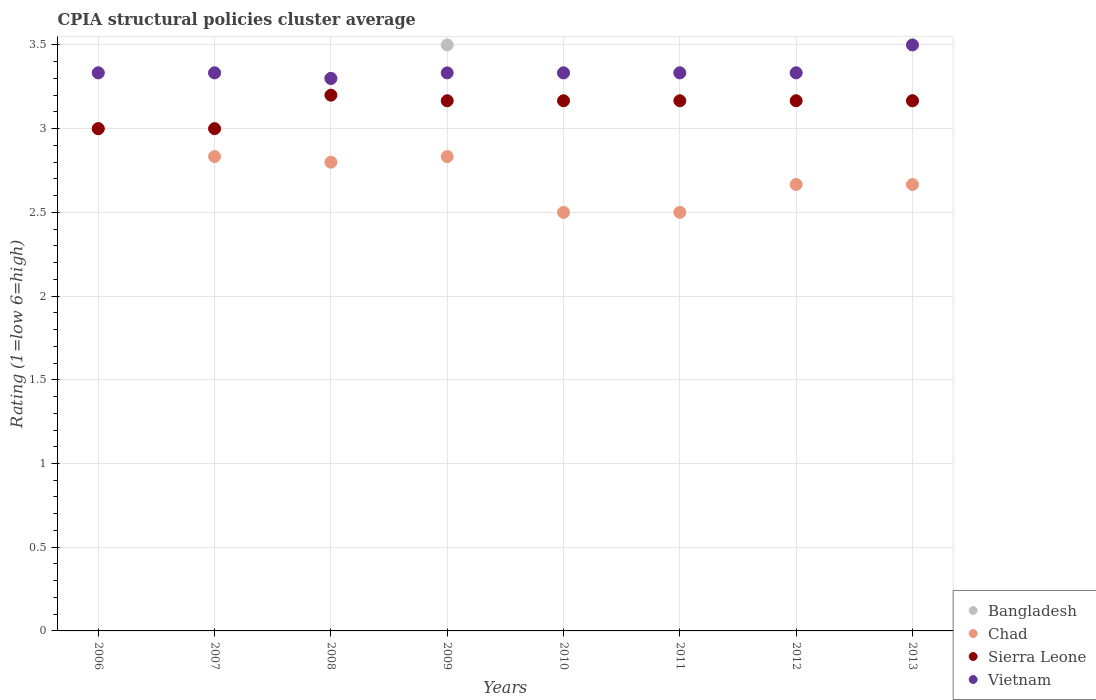How many different coloured dotlines are there?
Your answer should be very brief. 4. Is the number of dotlines equal to the number of legend labels?
Provide a short and direct response. Yes. What is the CPIA rating in Bangladesh in 2012?
Your response must be concise. 3.33. Across all years, what is the maximum CPIA rating in Bangladesh?
Keep it short and to the point. 3.5. What is the total CPIA rating in Bangladesh in the graph?
Provide a succinct answer. 26.63. What is the difference between the CPIA rating in Chad in 2006 and the CPIA rating in Vietnam in 2010?
Your response must be concise. -0.33. What is the average CPIA rating in Chad per year?
Your response must be concise. 2.72. In the year 2007, what is the difference between the CPIA rating in Chad and CPIA rating in Vietnam?
Your response must be concise. -0.5. Is the CPIA rating in Vietnam in 2008 less than that in 2010?
Your response must be concise. Yes. What is the difference between the highest and the second highest CPIA rating in Bangladesh?
Provide a succinct answer. 0.17. What is the difference between the highest and the lowest CPIA rating in Bangladesh?
Your answer should be very brief. 0.33. Is the sum of the CPIA rating in Vietnam in 2007 and 2010 greater than the maximum CPIA rating in Bangladesh across all years?
Give a very brief answer. Yes. Is it the case that in every year, the sum of the CPIA rating in Sierra Leone and CPIA rating in Chad  is greater than the sum of CPIA rating in Bangladesh and CPIA rating in Vietnam?
Ensure brevity in your answer.  No. Does the CPIA rating in Bangladesh monotonically increase over the years?
Offer a terse response. No. Is the CPIA rating in Bangladesh strictly less than the CPIA rating in Sierra Leone over the years?
Your answer should be compact. No. How many years are there in the graph?
Keep it short and to the point. 8. Does the graph contain any zero values?
Ensure brevity in your answer.  No. Where does the legend appear in the graph?
Offer a terse response. Bottom right. How are the legend labels stacked?
Give a very brief answer. Vertical. What is the title of the graph?
Provide a short and direct response. CPIA structural policies cluster average. What is the Rating (1=low 6=high) in Bangladesh in 2006?
Your answer should be very brief. 3.33. What is the Rating (1=low 6=high) in Sierra Leone in 2006?
Give a very brief answer. 3. What is the Rating (1=low 6=high) in Vietnam in 2006?
Your answer should be very brief. 3.33. What is the Rating (1=low 6=high) of Bangladesh in 2007?
Keep it short and to the point. 3.33. What is the Rating (1=low 6=high) of Chad in 2007?
Your answer should be very brief. 2.83. What is the Rating (1=low 6=high) of Vietnam in 2007?
Offer a very short reply. 3.33. What is the Rating (1=low 6=high) in Bangladesh in 2008?
Your response must be concise. 3.3. What is the Rating (1=low 6=high) of Chad in 2008?
Keep it short and to the point. 2.8. What is the Rating (1=low 6=high) in Sierra Leone in 2008?
Provide a succinct answer. 3.2. What is the Rating (1=low 6=high) of Vietnam in 2008?
Your response must be concise. 3.3. What is the Rating (1=low 6=high) in Bangladesh in 2009?
Ensure brevity in your answer.  3.5. What is the Rating (1=low 6=high) in Chad in 2009?
Make the answer very short. 2.83. What is the Rating (1=low 6=high) of Sierra Leone in 2009?
Your response must be concise. 3.17. What is the Rating (1=low 6=high) of Vietnam in 2009?
Make the answer very short. 3.33. What is the Rating (1=low 6=high) in Bangladesh in 2010?
Offer a very short reply. 3.33. What is the Rating (1=low 6=high) in Sierra Leone in 2010?
Your answer should be very brief. 3.17. What is the Rating (1=low 6=high) in Vietnam in 2010?
Make the answer very short. 3.33. What is the Rating (1=low 6=high) of Bangladesh in 2011?
Provide a succinct answer. 3.33. What is the Rating (1=low 6=high) in Sierra Leone in 2011?
Your answer should be compact. 3.17. What is the Rating (1=low 6=high) of Vietnam in 2011?
Keep it short and to the point. 3.33. What is the Rating (1=low 6=high) in Bangladesh in 2012?
Make the answer very short. 3.33. What is the Rating (1=low 6=high) in Chad in 2012?
Offer a terse response. 2.67. What is the Rating (1=low 6=high) in Sierra Leone in 2012?
Ensure brevity in your answer.  3.17. What is the Rating (1=low 6=high) in Vietnam in 2012?
Your answer should be compact. 3.33. What is the Rating (1=low 6=high) in Bangladesh in 2013?
Your response must be concise. 3.17. What is the Rating (1=low 6=high) of Chad in 2013?
Make the answer very short. 2.67. What is the Rating (1=low 6=high) of Sierra Leone in 2013?
Your response must be concise. 3.17. What is the Rating (1=low 6=high) in Vietnam in 2013?
Offer a terse response. 3.5. Across all years, what is the maximum Rating (1=low 6=high) in Chad?
Keep it short and to the point. 3. Across all years, what is the maximum Rating (1=low 6=high) in Vietnam?
Your answer should be compact. 3.5. Across all years, what is the minimum Rating (1=low 6=high) in Bangladesh?
Your answer should be compact. 3.17. What is the total Rating (1=low 6=high) in Bangladesh in the graph?
Offer a terse response. 26.63. What is the total Rating (1=low 6=high) of Chad in the graph?
Provide a short and direct response. 21.8. What is the total Rating (1=low 6=high) in Sierra Leone in the graph?
Ensure brevity in your answer.  25.03. What is the total Rating (1=low 6=high) of Vietnam in the graph?
Offer a terse response. 26.8. What is the difference between the Rating (1=low 6=high) of Bangladesh in 2006 and that in 2007?
Give a very brief answer. 0. What is the difference between the Rating (1=low 6=high) in Chad in 2006 and that in 2007?
Provide a short and direct response. 0.17. What is the difference between the Rating (1=low 6=high) of Sierra Leone in 2006 and that in 2007?
Ensure brevity in your answer.  0. What is the difference between the Rating (1=low 6=high) in Vietnam in 2006 and that in 2007?
Your answer should be compact. 0. What is the difference between the Rating (1=low 6=high) in Chad in 2006 and that in 2008?
Provide a succinct answer. 0.2. What is the difference between the Rating (1=low 6=high) of Vietnam in 2006 and that in 2008?
Your answer should be very brief. 0.03. What is the difference between the Rating (1=low 6=high) of Chad in 2006 and that in 2009?
Your answer should be compact. 0.17. What is the difference between the Rating (1=low 6=high) in Sierra Leone in 2006 and that in 2009?
Ensure brevity in your answer.  -0.17. What is the difference between the Rating (1=low 6=high) in Bangladesh in 2006 and that in 2010?
Ensure brevity in your answer.  0. What is the difference between the Rating (1=low 6=high) of Sierra Leone in 2006 and that in 2010?
Keep it short and to the point. -0.17. What is the difference between the Rating (1=low 6=high) in Vietnam in 2006 and that in 2010?
Offer a very short reply. 0. What is the difference between the Rating (1=low 6=high) in Vietnam in 2006 and that in 2011?
Provide a succinct answer. 0. What is the difference between the Rating (1=low 6=high) of Bangladesh in 2006 and that in 2013?
Your answer should be compact. 0.17. What is the difference between the Rating (1=low 6=high) in Chad in 2006 and that in 2013?
Make the answer very short. 0.33. What is the difference between the Rating (1=low 6=high) of Sierra Leone in 2006 and that in 2013?
Give a very brief answer. -0.17. What is the difference between the Rating (1=low 6=high) in Bangladesh in 2007 and that in 2008?
Provide a succinct answer. 0.03. What is the difference between the Rating (1=low 6=high) in Chad in 2007 and that in 2008?
Your answer should be very brief. 0.03. What is the difference between the Rating (1=low 6=high) in Sierra Leone in 2007 and that in 2008?
Offer a very short reply. -0.2. What is the difference between the Rating (1=low 6=high) of Vietnam in 2007 and that in 2008?
Your response must be concise. 0.03. What is the difference between the Rating (1=low 6=high) of Chad in 2007 and that in 2009?
Ensure brevity in your answer.  0. What is the difference between the Rating (1=low 6=high) in Sierra Leone in 2007 and that in 2009?
Offer a very short reply. -0.17. What is the difference between the Rating (1=low 6=high) in Vietnam in 2007 and that in 2009?
Keep it short and to the point. 0. What is the difference between the Rating (1=low 6=high) of Sierra Leone in 2007 and that in 2010?
Your response must be concise. -0.17. What is the difference between the Rating (1=low 6=high) of Vietnam in 2007 and that in 2010?
Your answer should be very brief. 0. What is the difference between the Rating (1=low 6=high) in Sierra Leone in 2007 and that in 2012?
Keep it short and to the point. -0.17. What is the difference between the Rating (1=low 6=high) of Bangladesh in 2007 and that in 2013?
Your response must be concise. 0.17. What is the difference between the Rating (1=low 6=high) of Chad in 2007 and that in 2013?
Keep it short and to the point. 0.17. What is the difference between the Rating (1=low 6=high) of Vietnam in 2007 and that in 2013?
Offer a terse response. -0.17. What is the difference between the Rating (1=low 6=high) of Chad in 2008 and that in 2009?
Your response must be concise. -0.03. What is the difference between the Rating (1=low 6=high) of Vietnam in 2008 and that in 2009?
Keep it short and to the point. -0.03. What is the difference between the Rating (1=low 6=high) in Bangladesh in 2008 and that in 2010?
Provide a short and direct response. -0.03. What is the difference between the Rating (1=low 6=high) of Vietnam in 2008 and that in 2010?
Keep it short and to the point. -0.03. What is the difference between the Rating (1=low 6=high) in Bangladesh in 2008 and that in 2011?
Provide a short and direct response. -0.03. What is the difference between the Rating (1=low 6=high) of Chad in 2008 and that in 2011?
Offer a very short reply. 0.3. What is the difference between the Rating (1=low 6=high) in Vietnam in 2008 and that in 2011?
Your answer should be very brief. -0.03. What is the difference between the Rating (1=low 6=high) in Bangladesh in 2008 and that in 2012?
Your answer should be very brief. -0.03. What is the difference between the Rating (1=low 6=high) of Chad in 2008 and that in 2012?
Keep it short and to the point. 0.13. What is the difference between the Rating (1=low 6=high) of Vietnam in 2008 and that in 2012?
Give a very brief answer. -0.03. What is the difference between the Rating (1=low 6=high) in Bangladesh in 2008 and that in 2013?
Make the answer very short. 0.13. What is the difference between the Rating (1=low 6=high) of Chad in 2008 and that in 2013?
Your response must be concise. 0.13. What is the difference between the Rating (1=low 6=high) of Sierra Leone in 2008 and that in 2013?
Offer a very short reply. 0.03. What is the difference between the Rating (1=low 6=high) in Chad in 2009 and that in 2010?
Give a very brief answer. 0.33. What is the difference between the Rating (1=low 6=high) of Bangladesh in 2009 and that in 2011?
Keep it short and to the point. 0.17. What is the difference between the Rating (1=low 6=high) of Chad in 2009 and that in 2011?
Offer a terse response. 0.33. What is the difference between the Rating (1=low 6=high) in Bangladesh in 2009 and that in 2012?
Your response must be concise. 0.17. What is the difference between the Rating (1=low 6=high) in Chad in 2009 and that in 2012?
Your answer should be compact. 0.17. What is the difference between the Rating (1=low 6=high) of Chad in 2010 and that in 2011?
Provide a short and direct response. 0. What is the difference between the Rating (1=low 6=high) in Sierra Leone in 2010 and that in 2011?
Give a very brief answer. 0. What is the difference between the Rating (1=low 6=high) of Chad in 2010 and that in 2012?
Give a very brief answer. -0.17. What is the difference between the Rating (1=low 6=high) of Bangladesh in 2010 and that in 2013?
Your response must be concise. 0.17. What is the difference between the Rating (1=low 6=high) in Chad in 2010 and that in 2013?
Your answer should be very brief. -0.17. What is the difference between the Rating (1=low 6=high) in Sierra Leone in 2010 and that in 2013?
Ensure brevity in your answer.  0. What is the difference between the Rating (1=low 6=high) in Vietnam in 2010 and that in 2013?
Ensure brevity in your answer.  -0.17. What is the difference between the Rating (1=low 6=high) in Bangladesh in 2011 and that in 2012?
Your answer should be compact. 0. What is the difference between the Rating (1=low 6=high) in Sierra Leone in 2011 and that in 2012?
Your answer should be very brief. 0. What is the difference between the Rating (1=low 6=high) in Bangladesh in 2011 and that in 2013?
Provide a short and direct response. 0.17. What is the difference between the Rating (1=low 6=high) of Sierra Leone in 2011 and that in 2013?
Your answer should be compact. 0. What is the difference between the Rating (1=low 6=high) in Vietnam in 2011 and that in 2013?
Give a very brief answer. -0.17. What is the difference between the Rating (1=low 6=high) of Bangladesh in 2012 and that in 2013?
Provide a short and direct response. 0.17. What is the difference between the Rating (1=low 6=high) of Chad in 2012 and that in 2013?
Provide a short and direct response. 0. What is the difference between the Rating (1=low 6=high) in Sierra Leone in 2012 and that in 2013?
Offer a terse response. 0. What is the difference between the Rating (1=low 6=high) in Vietnam in 2012 and that in 2013?
Your response must be concise. -0.17. What is the difference between the Rating (1=low 6=high) of Bangladesh in 2006 and the Rating (1=low 6=high) of Vietnam in 2007?
Your answer should be very brief. 0. What is the difference between the Rating (1=low 6=high) of Chad in 2006 and the Rating (1=low 6=high) of Vietnam in 2007?
Your answer should be compact. -0.33. What is the difference between the Rating (1=low 6=high) of Bangladesh in 2006 and the Rating (1=low 6=high) of Chad in 2008?
Keep it short and to the point. 0.53. What is the difference between the Rating (1=low 6=high) in Bangladesh in 2006 and the Rating (1=low 6=high) in Sierra Leone in 2008?
Your response must be concise. 0.13. What is the difference between the Rating (1=low 6=high) of Bangladesh in 2006 and the Rating (1=low 6=high) of Vietnam in 2008?
Give a very brief answer. 0.03. What is the difference between the Rating (1=low 6=high) in Chad in 2006 and the Rating (1=low 6=high) in Sierra Leone in 2008?
Offer a very short reply. -0.2. What is the difference between the Rating (1=low 6=high) of Sierra Leone in 2006 and the Rating (1=low 6=high) of Vietnam in 2008?
Offer a very short reply. -0.3. What is the difference between the Rating (1=low 6=high) of Bangladesh in 2006 and the Rating (1=low 6=high) of Vietnam in 2009?
Ensure brevity in your answer.  0. What is the difference between the Rating (1=low 6=high) of Chad in 2006 and the Rating (1=low 6=high) of Sierra Leone in 2009?
Provide a succinct answer. -0.17. What is the difference between the Rating (1=low 6=high) in Chad in 2006 and the Rating (1=low 6=high) in Vietnam in 2009?
Your answer should be compact. -0.33. What is the difference between the Rating (1=low 6=high) in Sierra Leone in 2006 and the Rating (1=low 6=high) in Vietnam in 2009?
Your response must be concise. -0.33. What is the difference between the Rating (1=low 6=high) of Bangladesh in 2006 and the Rating (1=low 6=high) of Chad in 2010?
Give a very brief answer. 0.83. What is the difference between the Rating (1=low 6=high) in Bangladesh in 2006 and the Rating (1=low 6=high) in Sierra Leone in 2010?
Your answer should be compact. 0.17. What is the difference between the Rating (1=low 6=high) of Bangladesh in 2006 and the Rating (1=low 6=high) of Vietnam in 2010?
Make the answer very short. 0. What is the difference between the Rating (1=low 6=high) of Sierra Leone in 2006 and the Rating (1=low 6=high) of Vietnam in 2010?
Your answer should be very brief. -0.33. What is the difference between the Rating (1=low 6=high) in Chad in 2006 and the Rating (1=low 6=high) in Sierra Leone in 2011?
Ensure brevity in your answer.  -0.17. What is the difference between the Rating (1=low 6=high) of Bangladesh in 2006 and the Rating (1=low 6=high) of Chad in 2012?
Give a very brief answer. 0.67. What is the difference between the Rating (1=low 6=high) in Bangladesh in 2006 and the Rating (1=low 6=high) in Vietnam in 2012?
Ensure brevity in your answer.  0. What is the difference between the Rating (1=low 6=high) in Chad in 2006 and the Rating (1=low 6=high) in Sierra Leone in 2012?
Your response must be concise. -0.17. What is the difference between the Rating (1=low 6=high) of Chad in 2006 and the Rating (1=low 6=high) of Vietnam in 2012?
Provide a short and direct response. -0.33. What is the difference between the Rating (1=low 6=high) in Sierra Leone in 2006 and the Rating (1=low 6=high) in Vietnam in 2012?
Keep it short and to the point. -0.33. What is the difference between the Rating (1=low 6=high) in Bangladesh in 2006 and the Rating (1=low 6=high) in Chad in 2013?
Offer a terse response. 0.67. What is the difference between the Rating (1=low 6=high) in Bangladesh in 2006 and the Rating (1=low 6=high) in Sierra Leone in 2013?
Provide a short and direct response. 0.17. What is the difference between the Rating (1=low 6=high) in Bangladesh in 2006 and the Rating (1=low 6=high) in Vietnam in 2013?
Your answer should be very brief. -0.17. What is the difference between the Rating (1=low 6=high) in Chad in 2006 and the Rating (1=low 6=high) in Sierra Leone in 2013?
Ensure brevity in your answer.  -0.17. What is the difference between the Rating (1=low 6=high) of Chad in 2006 and the Rating (1=low 6=high) of Vietnam in 2013?
Offer a very short reply. -0.5. What is the difference between the Rating (1=low 6=high) in Bangladesh in 2007 and the Rating (1=low 6=high) in Chad in 2008?
Offer a terse response. 0.53. What is the difference between the Rating (1=low 6=high) in Bangladesh in 2007 and the Rating (1=low 6=high) in Sierra Leone in 2008?
Provide a short and direct response. 0.13. What is the difference between the Rating (1=low 6=high) in Bangladesh in 2007 and the Rating (1=low 6=high) in Vietnam in 2008?
Keep it short and to the point. 0.03. What is the difference between the Rating (1=low 6=high) in Chad in 2007 and the Rating (1=low 6=high) in Sierra Leone in 2008?
Give a very brief answer. -0.37. What is the difference between the Rating (1=low 6=high) of Chad in 2007 and the Rating (1=low 6=high) of Vietnam in 2008?
Offer a very short reply. -0.47. What is the difference between the Rating (1=low 6=high) in Bangladesh in 2007 and the Rating (1=low 6=high) in Chad in 2009?
Provide a succinct answer. 0.5. What is the difference between the Rating (1=low 6=high) of Bangladesh in 2007 and the Rating (1=low 6=high) of Sierra Leone in 2009?
Your response must be concise. 0.17. What is the difference between the Rating (1=low 6=high) in Bangladesh in 2007 and the Rating (1=low 6=high) in Vietnam in 2009?
Your response must be concise. 0. What is the difference between the Rating (1=low 6=high) of Chad in 2007 and the Rating (1=low 6=high) of Sierra Leone in 2009?
Give a very brief answer. -0.33. What is the difference between the Rating (1=low 6=high) in Chad in 2007 and the Rating (1=low 6=high) in Vietnam in 2009?
Offer a very short reply. -0.5. What is the difference between the Rating (1=low 6=high) of Bangladesh in 2007 and the Rating (1=low 6=high) of Sierra Leone in 2010?
Offer a very short reply. 0.17. What is the difference between the Rating (1=low 6=high) of Chad in 2007 and the Rating (1=low 6=high) of Sierra Leone in 2010?
Keep it short and to the point. -0.33. What is the difference between the Rating (1=low 6=high) in Chad in 2007 and the Rating (1=low 6=high) in Vietnam in 2010?
Offer a terse response. -0.5. What is the difference between the Rating (1=low 6=high) in Sierra Leone in 2007 and the Rating (1=low 6=high) in Vietnam in 2010?
Offer a terse response. -0.33. What is the difference between the Rating (1=low 6=high) of Bangladesh in 2007 and the Rating (1=low 6=high) of Chad in 2011?
Provide a short and direct response. 0.83. What is the difference between the Rating (1=low 6=high) of Bangladesh in 2007 and the Rating (1=low 6=high) of Sierra Leone in 2011?
Your response must be concise. 0.17. What is the difference between the Rating (1=low 6=high) in Bangladesh in 2007 and the Rating (1=low 6=high) in Vietnam in 2011?
Your response must be concise. 0. What is the difference between the Rating (1=low 6=high) of Chad in 2007 and the Rating (1=low 6=high) of Sierra Leone in 2011?
Your response must be concise. -0.33. What is the difference between the Rating (1=low 6=high) of Chad in 2007 and the Rating (1=low 6=high) of Vietnam in 2011?
Ensure brevity in your answer.  -0.5. What is the difference between the Rating (1=low 6=high) in Bangladesh in 2007 and the Rating (1=low 6=high) in Chad in 2012?
Your response must be concise. 0.67. What is the difference between the Rating (1=low 6=high) of Bangladesh in 2007 and the Rating (1=low 6=high) of Vietnam in 2012?
Provide a succinct answer. 0. What is the difference between the Rating (1=low 6=high) of Chad in 2007 and the Rating (1=low 6=high) of Sierra Leone in 2012?
Give a very brief answer. -0.33. What is the difference between the Rating (1=low 6=high) in Chad in 2007 and the Rating (1=low 6=high) in Vietnam in 2012?
Make the answer very short. -0.5. What is the difference between the Rating (1=low 6=high) in Sierra Leone in 2007 and the Rating (1=low 6=high) in Vietnam in 2012?
Offer a very short reply. -0.33. What is the difference between the Rating (1=low 6=high) of Bangladesh in 2007 and the Rating (1=low 6=high) of Sierra Leone in 2013?
Give a very brief answer. 0.17. What is the difference between the Rating (1=low 6=high) in Bangladesh in 2007 and the Rating (1=low 6=high) in Vietnam in 2013?
Provide a short and direct response. -0.17. What is the difference between the Rating (1=low 6=high) of Chad in 2007 and the Rating (1=low 6=high) of Vietnam in 2013?
Make the answer very short. -0.67. What is the difference between the Rating (1=low 6=high) of Sierra Leone in 2007 and the Rating (1=low 6=high) of Vietnam in 2013?
Your answer should be very brief. -0.5. What is the difference between the Rating (1=low 6=high) in Bangladesh in 2008 and the Rating (1=low 6=high) in Chad in 2009?
Provide a short and direct response. 0.47. What is the difference between the Rating (1=low 6=high) in Bangladesh in 2008 and the Rating (1=low 6=high) in Sierra Leone in 2009?
Provide a short and direct response. 0.13. What is the difference between the Rating (1=low 6=high) of Bangladesh in 2008 and the Rating (1=low 6=high) of Vietnam in 2009?
Your response must be concise. -0.03. What is the difference between the Rating (1=low 6=high) in Chad in 2008 and the Rating (1=low 6=high) in Sierra Leone in 2009?
Provide a succinct answer. -0.37. What is the difference between the Rating (1=low 6=high) in Chad in 2008 and the Rating (1=low 6=high) in Vietnam in 2009?
Ensure brevity in your answer.  -0.53. What is the difference between the Rating (1=low 6=high) of Sierra Leone in 2008 and the Rating (1=low 6=high) of Vietnam in 2009?
Provide a succinct answer. -0.13. What is the difference between the Rating (1=low 6=high) in Bangladesh in 2008 and the Rating (1=low 6=high) in Sierra Leone in 2010?
Your answer should be compact. 0.13. What is the difference between the Rating (1=low 6=high) in Bangladesh in 2008 and the Rating (1=low 6=high) in Vietnam in 2010?
Your response must be concise. -0.03. What is the difference between the Rating (1=low 6=high) in Chad in 2008 and the Rating (1=low 6=high) in Sierra Leone in 2010?
Ensure brevity in your answer.  -0.37. What is the difference between the Rating (1=low 6=high) in Chad in 2008 and the Rating (1=low 6=high) in Vietnam in 2010?
Your answer should be very brief. -0.53. What is the difference between the Rating (1=low 6=high) of Sierra Leone in 2008 and the Rating (1=low 6=high) of Vietnam in 2010?
Give a very brief answer. -0.13. What is the difference between the Rating (1=low 6=high) in Bangladesh in 2008 and the Rating (1=low 6=high) in Sierra Leone in 2011?
Keep it short and to the point. 0.13. What is the difference between the Rating (1=low 6=high) in Bangladesh in 2008 and the Rating (1=low 6=high) in Vietnam in 2011?
Keep it short and to the point. -0.03. What is the difference between the Rating (1=low 6=high) of Chad in 2008 and the Rating (1=low 6=high) of Sierra Leone in 2011?
Keep it short and to the point. -0.37. What is the difference between the Rating (1=low 6=high) of Chad in 2008 and the Rating (1=low 6=high) of Vietnam in 2011?
Provide a short and direct response. -0.53. What is the difference between the Rating (1=low 6=high) of Sierra Leone in 2008 and the Rating (1=low 6=high) of Vietnam in 2011?
Provide a short and direct response. -0.13. What is the difference between the Rating (1=low 6=high) of Bangladesh in 2008 and the Rating (1=low 6=high) of Chad in 2012?
Keep it short and to the point. 0.63. What is the difference between the Rating (1=low 6=high) of Bangladesh in 2008 and the Rating (1=low 6=high) of Sierra Leone in 2012?
Provide a succinct answer. 0.13. What is the difference between the Rating (1=low 6=high) in Bangladesh in 2008 and the Rating (1=low 6=high) in Vietnam in 2012?
Keep it short and to the point. -0.03. What is the difference between the Rating (1=low 6=high) in Chad in 2008 and the Rating (1=low 6=high) in Sierra Leone in 2012?
Keep it short and to the point. -0.37. What is the difference between the Rating (1=low 6=high) in Chad in 2008 and the Rating (1=low 6=high) in Vietnam in 2012?
Give a very brief answer. -0.53. What is the difference between the Rating (1=low 6=high) of Sierra Leone in 2008 and the Rating (1=low 6=high) of Vietnam in 2012?
Your response must be concise. -0.13. What is the difference between the Rating (1=low 6=high) of Bangladesh in 2008 and the Rating (1=low 6=high) of Chad in 2013?
Provide a succinct answer. 0.63. What is the difference between the Rating (1=low 6=high) in Bangladesh in 2008 and the Rating (1=low 6=high) in Sierra Leone in 2013?
Give a very brief answer. 0.13. What is the difference between the Rating (1=low 6=high) of Chad in 2008 and the Rating (1=low 6=high) of Sierra Leone in 2013?
Offer a very short reply. -0.37. What is the difference between the Rating (1=low 6=high) in Chad in 2008 and the Rating (1=low 6=high) in Vietnam in 2013?
Provide a short and direct response. -0.7. What is the difference between the Rating (1=low 6=high) in Sierra Leone in 2008 and the Rating (1=low 6=high) in Vietnam in 2013?
Ensure brevity in your answer.  -0.3. What is the difference between the Rating (1=low 6=high) in Bangladesh in 2009 and the Rating (1=low 6=high) in Sierra Leone in 2012?
Provide a short and direct response. 0.33. What is the difference between the Rating (1=low 6=high) in Sierra Leone in 2009 and the Rating (1=low 6=high) in Vietnam in 2012?
Ensure brevity in your answer.  -0.17. What is the difference between the Rating (1=low 6=high) of Bangladesh in 2009 and the Rating (1=low 6=high) of Chad in 2013?
Provide a succinct answer. 0.83. What is the difference between the Rating (1=low 6=high) in Bangladesh in 2009 and the Rating (1=low 6=high) in Sierra Leone in 2013?
Provide a short and direct response. 0.33. What is the difference between the Rating (1=low 6=high) of Chad in 2009 and the Rating (1=low 6=high) of Sierra Leone in 2013?
Your answer should be very brief. -0.33. What is the difference between the Rating (1=low 6=high) of Chad in 2009 and the Rating (1=low 6=high) of Vietnam in 2013?
Your answer should be very brief. -0.67. What is the difference between the Rating (1=low 6=high) in Bangladesh in 2010 and the Rating (1=low 6=high) in Chad in 2011?
Make the answer very short. 0.83. What is the difference between the Rating (1=low 6=high) of Bangladesh in 2010 and the Rating (1=low 6=high) of Sierra Leone in 2011?
Your answer should be very brief. 0.17. What is the difference between the Rating (1=low 6=high) in Bangladesh in 2010 and the Rating (1=low 6=high) in Vietnam in 2011?
Make the answer very short. 0. What is the difference between the Rating (1=low 6=high) in Sierra Leone in 2010 and the Rating (1=low 6=high) in Vietnam in 2011?
Your response must be concise. -0.17. What is the difference between the Rating (1=low 6=high) of Bangladesh in 2010 and the Rating (1=low 6=high) of Chad in 2012?
Offer a terse response. 0.67. What is the difference between the Rating (1=low 6=high) of Bangladesh in 2010 and the Rating (1=low 6=high) of Sierra Leone in 2012?
Provide a succinct answer. 0.17. What is the difference between the Rating (1=low 6=high) of Bangladesh in 2010 and the Rating (1=low 6=high) of Vietnam in 2012?
Make the answer very short. 0. What is the difference between the Rating (1=low 6=high) of Bangladesh in 2010 and the Rating (1=low 6=high) of Sierra Leone in 2013?
Make the answer very short. 0.17. What is the difference between the Rating (1=low 6=high) of Chad in 2010 and the Rating (1=low 6=high) of Vietnam in 2013?
Make the answer very short. -1. What is the difference between the Rating (1=low 6=high) in Bangladesh in 2011 and the Rating (1=low 6=high) in Sierra Leone in 2012?
Provide a succinct answer. 0.17. What is the difference between the Rating (1=low 6=high) of Bangladesh in 2011 and the Rating (1=low 6=high) of Vietnam in 2012?
Offer a terse response. 0. What is the difference between the Rating (1=low 6=high) of Chad in 2011 and the Rating (1=low 6=high) of Sierra Leone in 2012?
Your response must be concise. -0.67. What is the difference between the Rating (1=low 6=high) in Chad in 2011 and the Rating (1=low 6=high) in Vietnam in 2012?
Offer a terse response. -0.83. What is the difference between the Rating (1=low 6=high) in Sierra Leone in 2011 and the Rating (1=low 6=high) in Vietnam in 2012?
Your answer should be compact. -0.17. What is the difference between the Rating (1=low 6=high) of Bangladesh in 2011 and the Rating (1=low 6=high) of Sierra Leone in 2013?
Provide a short and direct response. 0.17. What is the difference between the Rating (1=low 6=high) in Chad in 2011 and the Rating (1=low 6=high) in Sierra Leone in 2013?
Provide a succinct answer. -0.67. What is the difference between the Rating (1=low 6=high) of Chad in 2011 and the Rating (1=low 6=high) of Vietnam in 2013?
Provide a succinct answer. -1. What is the difference between the Rating (1=low 6=high) in Sierra Leone in 2011 and the Rating (1=low 6=high) in Vietnam in 2013?
Your response must be concise. -0.33. What is the difference between the Rating (1=low 6=high) of Bangladesh in 2012 and the Rating (1=low 6=high) of Vietnam in 2013?
Provide a succinct answer. -0.17. What is the difference between the Rating (1=low 6=high) in Chad in 2012 and the Rating (1=low 6=high) in Sierra Leone in 2013?
Make the answer very short. -0.5. What is the difference between the Rating (1=low 6=high) of Sierra Leone in 2012 and the Rating (1=low 6=high) of Vietnam in 2013?
Your response must be concise. -0.33. What is the average Rating (1=low 6=high) in Bangladesh per year?
Your answer should be compact. 3.33. What is the average Rating (1=low 6=high) in Chad per year?
Your answer should be compact. 2.73. What is the average Rating (1=low 6=high) in Sierra Leone per year?
Provide a succinct answer. 3.13. What is the average Rating (1=low 6=high) in Vietnam per year?
Provide a short and direct response. 3.35. In the year 2006, what is the difference between the Rating (1=low 6=high) in Bangladesh and Rating (1=low 6=high) in Vietnam?
Offer a terse response. 0. In the year 2006, what is the difference between the Rating (1=low 6=high) in Chad and Rating (1=low 6=high) in Vietnam?
Make the answer very short. -0.33. In the year 2007, what is the difference between the Rating (1=low 6=high) of Bangladesh and Rating (1=low 6=high) of Chad?
Provide a succinct answer. 0.5. In the year 2007, what is the difference between the Rating (1=low 6=high) in Bangladesh and Rating (1=low 6=high) in Sierra Leone?
Your answer should be compact. 0.33. In the year 2007, what is the difference between the Rating (1=low 6=high) of Chad and Rating (1=low 6=high) of Sierra Leone?
Offer a terse response. -0.17. In the year 2008, what is the difference between the Rating (1=low 6=high) in Bangladesh and Rating (1=low 6=high) in Chad?
Your response must be concise. 0.5. In the year 2008, what is the difference between the Rating (1=low 6=high) in Bangladesh and Rating (1=low 6=high) in Vietnam?
Offer a terse response. 0. In the year 2008, what is the difference between the Rating (1=low 6=high) in Chad and Rating (1=low 6=high) in Sierra Leone?
Offer a very short reply. -0.4. In the year 2009, what is the difference between the Rating (1=low 6=high) in Bangladesh and Rating (1=low 6=high) in Vietnam?
Provide a succinct answer. 0.17. In the year 2009, what is the difference between the Rating (1=low 6=high) of Chad and Rating (1=low 6=high) of Sierra Leone?
Offer a terse response. -0.33. In the year 2009, what is the difference between the Rating (1=low 6=high) in Sierra Leone and Rating (1=low 6=high) in Vietnam?
Keep it short and to the point. -0.17. In the year 2010, what is the difference between the Rating (1=low 6=high) in Bangladesh and Rating (1=low 6=high) in Chad?
Your answer should be very brief. 0.83. In the year 2010, what is the difference between the Rating (1=low 6=high) in Chad and Rating (1=low 6=high) in Sierra Leone?
Provide a short and direct response. -0.67. In the year 2010, what is the difference between the Rating (1=low 6=high) in Chad and Rating (1=low 6=high) in Vietnam?
Provide a succinct answer. -0.83. In the year 2011, what is the difference between the Rating (1=low 6=high) in Bangladesh and Rating (1=low 6=high) in Chad?
Your answer should be compact. 0.83. In the year 2011, what is the difference between the Rating (1=low 6=high) of Chad and Rating (1=low 6=high) of Sierra Leone?
Your response must be concise. -0.67. In the year 2012, what is the difference between the Rating (1=low 6=high) in Bangladesh and Rating (1=low 6=high) in Sierra Leone?
Keep it short and to the point. 0.17. In the year 2012, what is the difference between the Rating (1=low 6=high) in Bangladesh and Rating (1=low 6=high) in Vietnam?
Ensure brevity in your answer.  0. In the year 2012, what is the difference between the Rating (1=low 6=high) of Chad and Rating (1=low 6=high) of Vietnam?
Keep it short and to the point. -0.67. In the year 2013, what is the difference between the Rating (1=low 6=high) of Bangladesh and Rating (1=low 6=high) of Vietnam?
Make the answer very short. -0.33. In the year 2013, what is the difference between the Rating (1=low 6=high) of Chad and Rating (1=low 6=high) of Sierra Leone?
Your response must be concise. -0.5. In the year 2013, what is the difference between the Rating (1=low 6=high) in Chad and Rating (1=low 6=high) in Vietnam?
Provide a succinct answer. -0.83. What is the ratio of the Rating (1=low 6=high) of Chad in 2006 to that in 2007?
Give a very brief answer. 1.06. What is the ratio of the Rating (1=low 6=high) in Vietnam in 2006 to that in 2007?
Make the answer very short. 1. What is the ratio of the Rating (1=low 6=high) in Bangladesh in 2006 to that in 2008?
Offer a very short reply. 1.01. What is the ratio of the Rating (1=low 6=high) in Chad in 2006 to that in 2008?
Offer a very short reply. 1.07. What is the ratio of the Rating (1=low 6=high) of Sierra Leone in 2006 to that in 2008?
Offer a terse response. 0.94. What is the ratio of the Rating (1=low 6=high) of Vietnam in 2006 to that in 2008?
Your answer should be compact. 1.01. What is the ratio of the Rating (1=low 6=high) of Bangladesh in 2006 to that in 2009?
Offer a very short reply. 0.95. What is the ratio of the Rating (1=low 6=high) in Chad in 2006 to that in 2009?
Your answer should be compact. 1.06. What is the ratio of the Rating (1=low 6=high) of Chad in 2006 to that in 2010?
Offer a very short reply. 1.2. What is the ratio of the Rating (1=low 6=high) in Sierra Leone in 2006 to that in 2010?
Your answer should be very brief. 0.95. What is the ratio of the Rating (1=low 6=high) of Vietnam in 2006 to that in 2010?
Provide a short and direct response. 1. What is the ratio of the Rating (1=low 6=high) of Bangladesh in 2006 to that in 2011?
Ensure brevity in your answer.  1. What is the ratio of the Rating (1=low 6=high) in Sierra Leone in 2006 to that in 2012?
Your answer should be compact. 0.95. What is the ratio of the Rating (1=low 6=high) of Bangladesh in 2006 to that in 2013?
Your answer should be very brief. 1.05. What is the ratio of the Rating (1=low 6=high) in Chad in 2006 to that in 2013?
Give a very brief answer. 1.12. What is the ratio of the Rating (1=low 6=high) of Vietnam in 2006 to that in 2013?
Provide a short and direct response. 0.95. What is the ratio of the Rating (1=low 6=high) in Chad in 2007 to that in 2008?
Keep it short and to the point. 1.01. What is the ratio of the Rating (1=low 6=high) of Sierra Leone in 2007 to that in 2008?
Make the answer very short. 0.94. What is the ratio of the Rating (1=low 6=high) of Vietnam in 2007 to that in 2008?
Offer a very short reply. 1.01. What is the ratio of the Rating (1=low 6=high) of Bangladesh in 2007 to that in 2009?
Your answer should be compact. 0.95. What is the ratio of the Rating (1=low 6=high) in Chad in 2007 to that in 2009?
Your answer should be very brief. 1. What is the ratio of the Rating (1=low 6=high) in Sierra Leone in 2007 to that in 2009?
Keep it short and to the point. 0.95. What is the ratio of the Rating (1=low 6=high) of Bangladesh in 2007 to that in 2010?
Your answer should be very brief. 1. What is the ratio of the Rating (1=low 6=high) in Chad in 2007 to that in 2010?
Your answer should be compact. 1.13. What is the ratio of the Rating (1=low 6=high) in Sierra Leone in 2007 to that in 2010?
Keep it short and to the point. 0.95. What is the ratio of the Rating (1=low 6=high) in Vietnam in 2007 to that in 2010?
Provide a succinct answer. 1. What is the ratio of the Rating (1=low 6=high) of Bangladesh in 2007 to that in 2011?
Offer a terse response. 1. What is the ratio of the Rating (1=low 6=high) of Chad in 2007 to that in 2011?
Give a very brief answer. 1.13. What is the ratio of the Rating (1=low 6=high) of Sierra Leone in 2007 to that in 2012?
Keep it short and to the point. 0.95. What is the ratio of the Rating (1=low 6=high) of Vietnam in 2007 to that in 2012?
Your response must be concise. 1. What is the ratio of the Rating (1=low 6=high) of Bangladesh in 2007 to that in 2013?
Provide a succinct answer. 1.05. What is the ratio of the Rating (1=low 6=high) of Bangladesh in 2008 to that in 2009?
Ensure brevity in your answer.  0.94. What is the ratio of the Rating (1=low 6=high) of Chad in 2008 to that in 2009?
Make the answer very short. 0.99. What is the ratio of the Rating (1=low 6=high) in Sierra Leone in 2008 to that in 2009?
Your answer should be compact. 1.01. What is the ratio of the Rating (1=low 6=high) of Vietnam in 2008 to that in 2009?
Offer a very short reply. 0.99. What is the ratio of the Rating (1=low 6=high) of Bangladesh in 2008 to that in 2010?
Your response must be concise. 0.99. What is the ratio of the Rating (1=low 6=high) in Chad in 2008 to that in 2010?
Your answer should be compact. 1.12. What is the ratio of the Rating (1=low 6=high) in Sierra Leone in 2008 to that in 2010?
Keep it short and to the point. 1.01. What is the ratio of the Rating (1=low 6=high) in Bangladesh in 2008 to that in 2011?
Your answer should be very brief. 0.99. What is the ratio of the Rating (1=low 6=high) of Chad in 2008 to that in 2011?
Your answer should be very brief. 1.12. What is the ratio of the Rating (1=low 6=high) of Sierra Leone in 2008 to that in 2011?
Provide a short and direct response. 1.01. What is the ratio of the Rating (1=low 6=high) in Bangladesh in 2008 to that in 2012?
Ensure brevity in your answer.  0.99. What is the ratio of the Rating (1=low 6=high) in Sierra Leone in 2008 to that in 2012?
Provide a short and direct response. 1.01. What is the ratio of the Rating (1=low 6=high) of Bangladesh in 2008 to that in 2013?
Provide a succinct answer. 1.04. What is the ratio of the Rating (1=low 6=high) of Sierra Leone in 2008 to that in 2013?
Provide a succinct answer. 1.01. What is the ratio of the Rating (1=low 6=high) in Vietnam in 2008 to that in 2013?
Provide a short and direct response. 0.94. What is the ratio of the Rating (1=low 6=high) in Bangladesh in 2009 to that in 2010?
Ensure brevity in your answer.  1.05. What is the ratio of the Rating (1=low 6=high) of Chad in 2009 to that in 2010?
Your answer should be very brief. 1.13. What is the ratio of the Rating (1=low 6=high) of Sierra Leone in 2009 to that in 2010?
Offer a terse response. 1. What is the ratio of the Rating (1=low 6=high) of Chad in 2009 to that in 2011?
Your answer should be compact. 1.13. What is the ratio of the Rating (1=low 6=high) in Sierra Leone in 2009 to that in 2011?
Ensure brevity in your answer.  1. What is the ratio of the Rating (1=low 6=high) of Vietnam in 2009 to that in 2011?
Your answer should be compact. 1. What is the ratio of the Rating (1=low 6=high) of Bangladesh in 2009 to that in 2012?
Keep it short and to the point. 1.05. What is the ratio of the Rating (1=low 6=high) in Sierra Leone in 2009 to that in 2012?
Provide a short and direct response. 1. What is the ratio of the Rating (1=low 6=high) of Vietnam in 2009 to that in 2012?
Offer a very short reply. 1. What is the ratio of the Rating (1=low 6=high) of Bangladesh in 2009 to that in 2013?
Provide a short and direct response. 1.11. What is the ratio of the Rating (1=low 6=high) of Chad in 2009 to that in 2013?
Provide a short and direct response. 1.06. What is the ratio of the Rating (1=low 6=high) of Bangladesh in 2010 to that in 2013?
Offer a very short reply. 1.05. What is the ratio of the Rating (1=low 6=high) of Chad in 2010 to that in 2013?
Offer a very short reply. 0.94. What is the ratio of the Rating (1=low 6=high) of Bangladesh in 2011 to that in 2013?
Offer a very short reply. 1.05. What is the ratio of the Rating (1=low 6=high) in Chad in 2011 to that in 2013?
Your response must be concise. 0.94. What is the ratio of the Rating (1=low 6=high) of Sierra Leone in 2011 to that in 2013?
Give a very brief answer. 1. What is the ratio of the Rating (1=low 6=high) in Vietnam in 2011 to that in 2013?
Offer a terse response. 0.95. What is the ratio of the Rating (1=low 6=high) in Bangladesh in 2012 to that in 2013?
Ensure brevity in your answer.  1.05. What is the difference between the highest and the second highest Rating (1=low 6=high) of Bangladesh?
Offer a very short reply. 0.17. What is the difference between the highest and the second highest Rating (1=low 6=high) of Chad?
Your answer should be very brief. 0.17. What is the difference between the highest and the second highest Rating (1=low 6=high) in Sierra Leone?
Ensure brevity in your answer.  0.03. What is the difference between the highest and the lowest Rating (1=low 6=high) of Sierra Leone?
Ensure brevity in your answer.  0.2. What is the difference between the highest and the lowest Rating (1=low 6=high) in Vietnam?
Offer a very short reply. 0.2. 